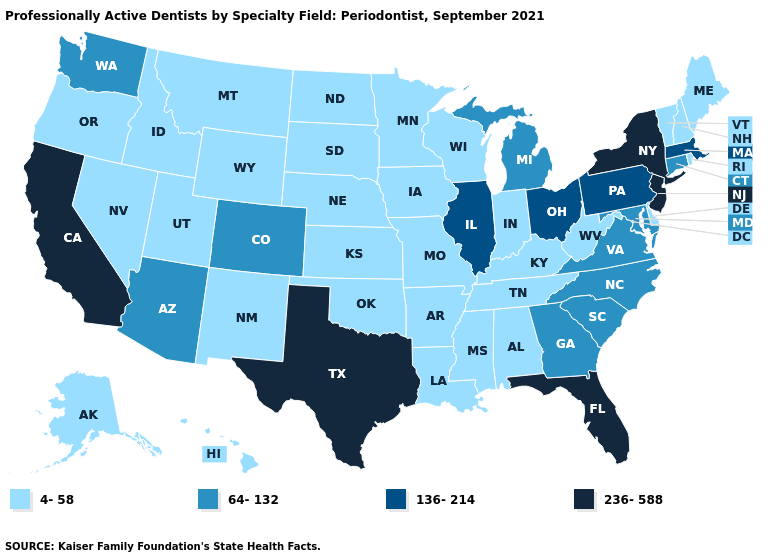Name the states that have a value in the range 64-132?
Keep it brief. Arizona, Colorado, Connecticut, Georgia, Maryland, Michigan, North Carolina, South Carolina, Virginia, Washington. Name the states that have a value in the range 4-58?
Short answer required. Alabama, Alaska, Arkansas, Delaware, Hawaii, Idaho, Indiana, Iowa, Kansas, Kentucky, Louisiana, Maine, Minnesota, Mississippi, Missouri, Montana, Nebraska, Nevada, New Hampshire, New Mexico, North Dakota, Oklahoma, Oregon, Rhode Island, South Dakota, Tennessee, Utah, Vermont, West Virginia, Wisconsin, Wyoming. Which states have the lowest value in the South?
Short answer required. Alabama, Arkansas, Delaware, Kentucky, Louisiana, Mississippi, Oklahoma, Tennessee, West Virginia. Does New Jersey have a higher value than New York?
Answer briefly. No. Among the states that border Pennsylvania , does Delaware have the lowest value?
Write a very short answer. Yes. What is the value of California?
Answer briefly. 236-588. What is the highest value in states that border Kentucky?
Short answer required. 136-214. Among the states that border Delaware , does Maryland have the lowest value?
Give a very brief answer. Yes. Name the states that have a value in the range 64-132?
Short answer required. Arizona, Colorado, Connecticut, Georgia, Maryland, Michigan, North Carolina, South Carolina, Virginia, Washington. Does the first symbol in the legend represent the smallest category?
Write a very short answer. Yes. What is the value of Massachusetts?
Give a very brief answer. 136-214. Name the states that have a value in the range 64-132?
Answer briefly. Arizona, Colorado, Connecticut, Georgia, Maryland, Michigan, North Carolina, South Carolina, Virginia, Washington. What is the lowest value in the Northeast?
Give a very brief answer. 4-58. Name the states that have a value in the range 236-588?
Concise answer only. California, Florida, New Jersey, New York, Texas. What is the highest value in the USA?
Concise answer only. 236-588. 